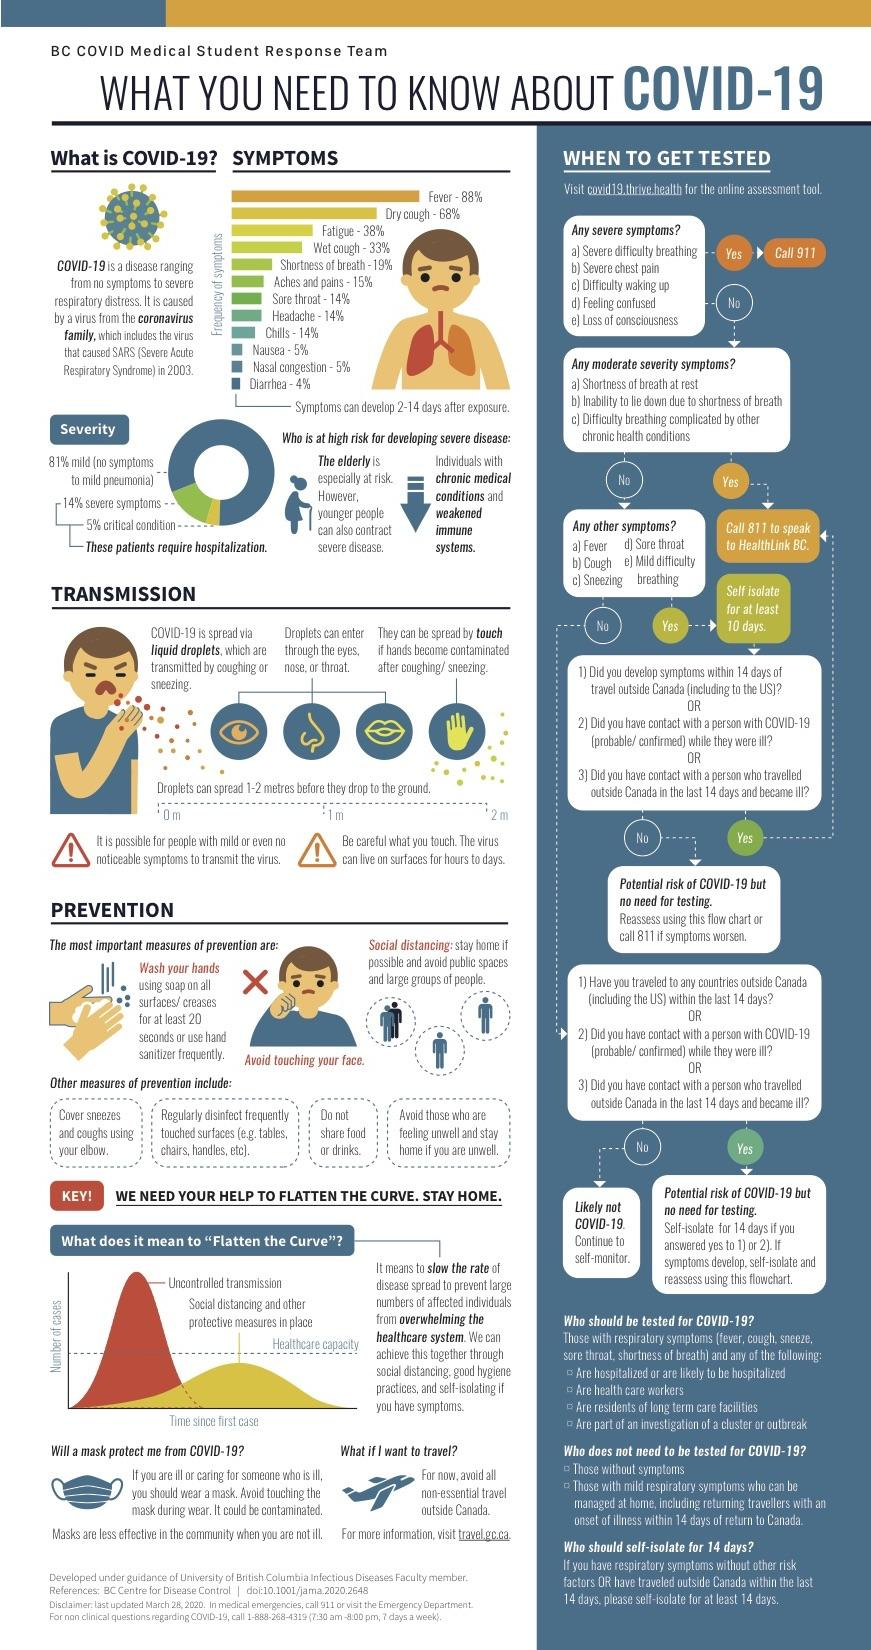Identify some key points in this picture. In the event of a moderate severity symptom, you should call 811 to obtain further assistance. If one experiences severe chest pain, it is imperative to immediately call 911 for medical assistance. It is stated that 7 methods for prevention are mentioned, including other measures. If you are unable to lie down due to shortness of breath, you should call 811 to speak to Healthlink BC immediately. In the event of a severe symptom, it is imperative to call 911 on the phone number. 